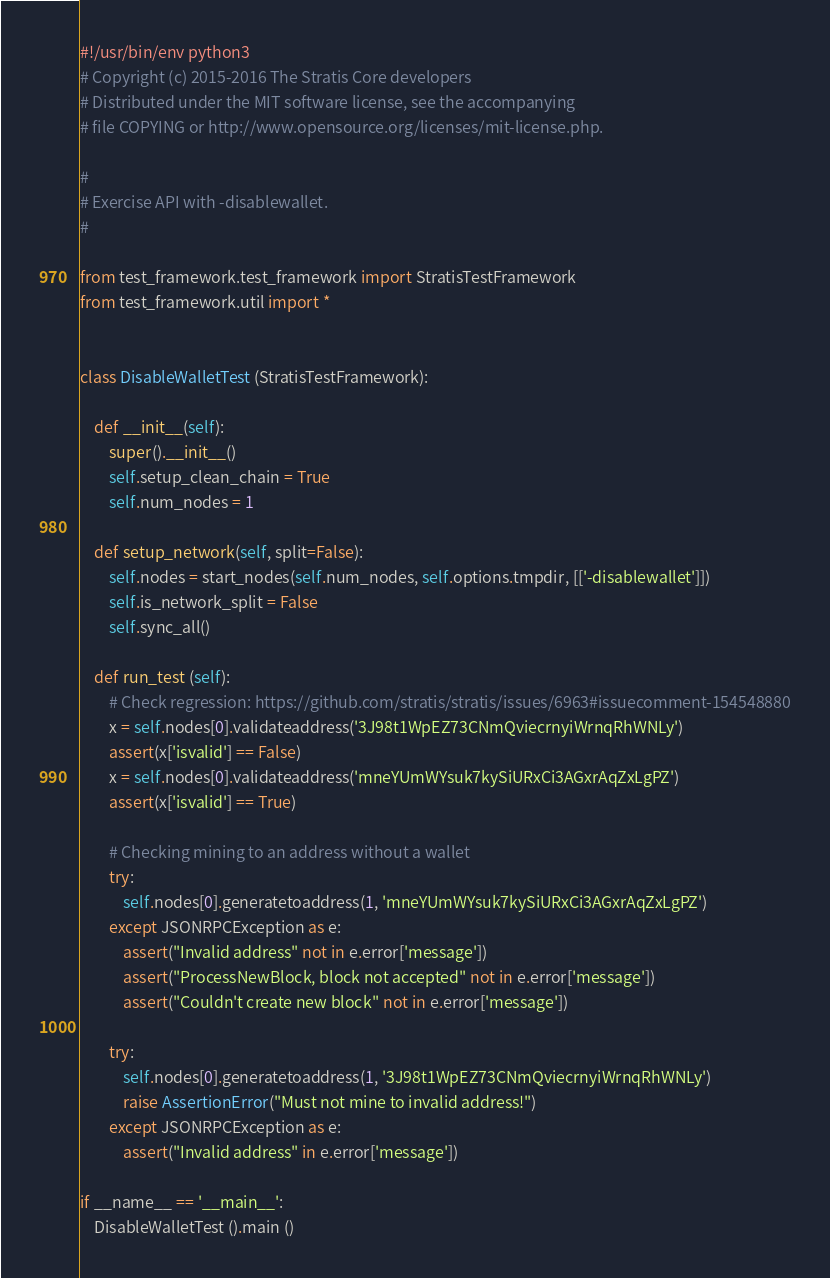<code> <loc_0><loc_0><loc_500><loc_500><_Python_>#!/usr/bin/env python3
# Copyright (c) 2015-2016 The Stratis Core developers
# Distributed under the MIT software license, see the accompanying
# file COPYING or http://www.opensource.org/licenses/mit-license.php.

#
# Exercise API with -disablewallet.
#

from test_framework.test_framework import StratisTestFramework
from test_framework.util import *


class DisableWalletTest (StratisTestFramework):

    def __init__(self):
        super().__init__()
        self.setup_clean_chain = True
        self.num_nodes = 1

    def setup_network(self, split=False):
        self.nodes = start_nodes(self.num_nodes, self.options.tmpdir, [['-disablewallet']])
        self.is_network_split = False
        self.sync_all()

    def run_test (self):
        # Check regression: https://github.com/stratis/stratis/issues/6963#issuecomment-154548880
        x = self.nodes[0].validateaddress('3J98t1WpEZ73CNmQviecrnyiWrnqRhWNLy')
        assert(x['isvalid'] == False)
        x = self.nodes[0].validateaddress('mneYUmWYsuk7kySiURxCi3AGxrAqZxLgPZ')
        assert(x['isvalid'] == True)

        # Checking mining to an address without a wallet
        try:
            self.nodes[0].generatetoaddress(1, 'mneYUmWYsuk7kySiURxCi3AGxrAqZxLgPZ')
        except JSONRPCException as e:
            assert("Invalid address" not in e.error['message'])
            assert("ProcessNewBlock, block not accepted" not in e.error['message'])
            assert("Couldn't create new block" not in e.error['message'])

        try:
            self.nodes[0].generatetoaddress(1, '3J98t1WpEZ73CNmQviecrnyiWrnqRhWNLy')
            raise AssertionError("Must not mine to invalid address!")
        except JSONRPCException as e:
            assert("Invalid address" in e.error['message'])

if __name__ == '__main__':
    DisableWalletTest ().main ()
</code> 